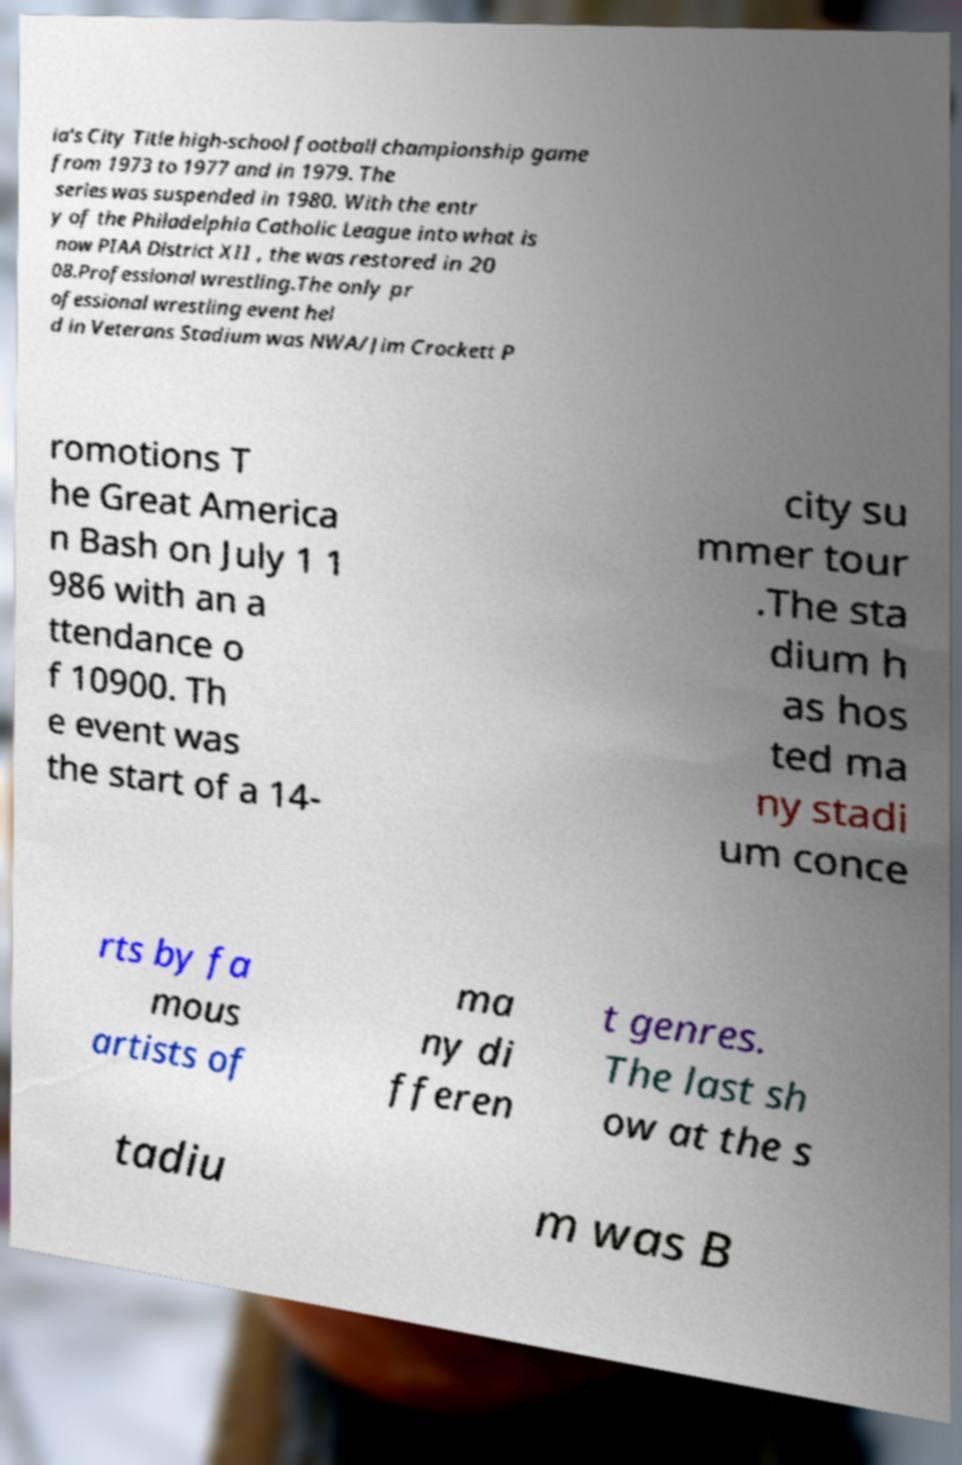Please read and relay the text visible in this image. What does it say? ia's City Title high-school football championship game from 1973 to 1977 and in 1979. The series was suspended in 1980. With the entr y of the Philadelphia Catholic League into what is now PIAA District XII , the was restored in 20 08.Professional wrestling.The only pr ofessional wrestling event hel d in Veterans Stadium was NWA/Jim Crockett P romotions T he Great America n Bash on July 1 1 986 with an a ttendance o f 10900. Th e event was the start of a 14- city su mmer tour .The sta dium h as hos ted ma ny stadi um conce rts by fa mous artists of ma ny di fferen t genres. The last sh ow at the s tadiu m was B 